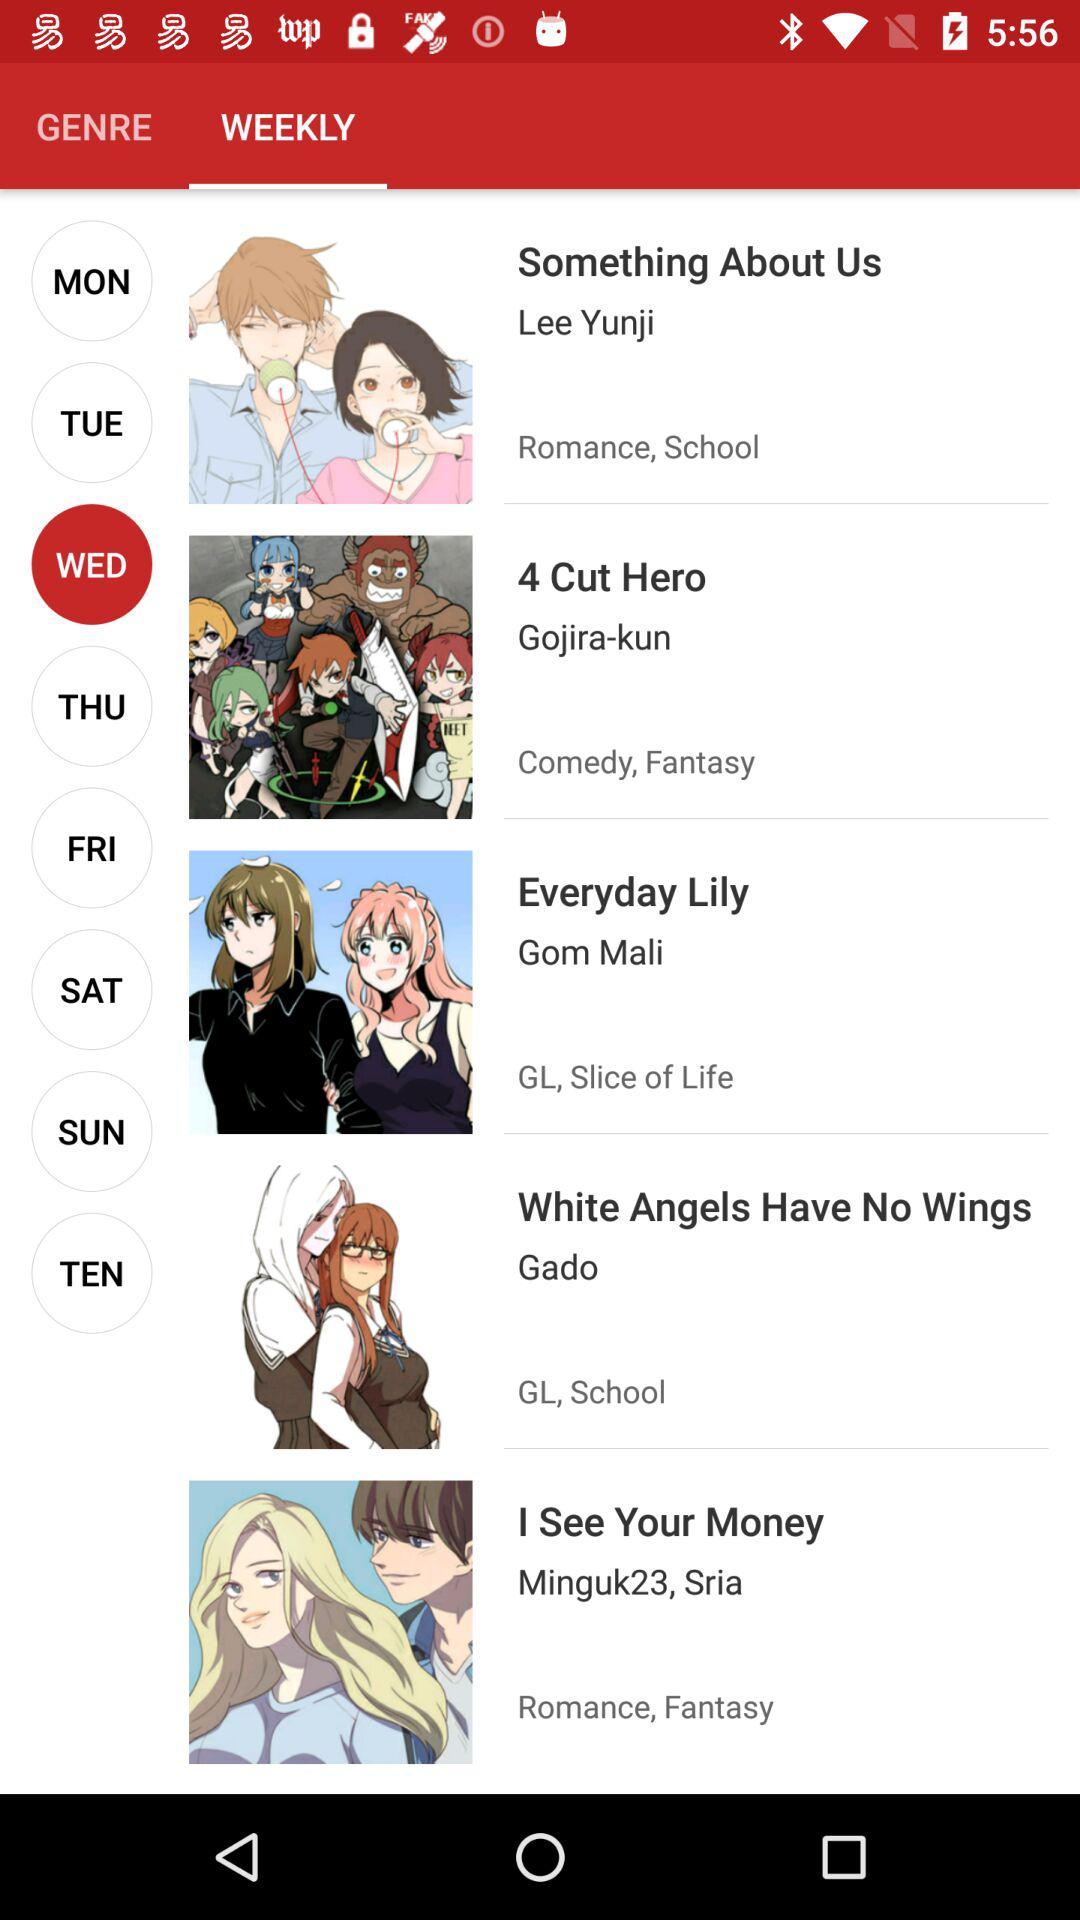What is the genre of "Something About Us"? The genre is "Romance, School". 